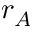Convert formula to latex. <formula><loc_0><loc_0><loc_500><loc_500>r _ { A }</formula> 